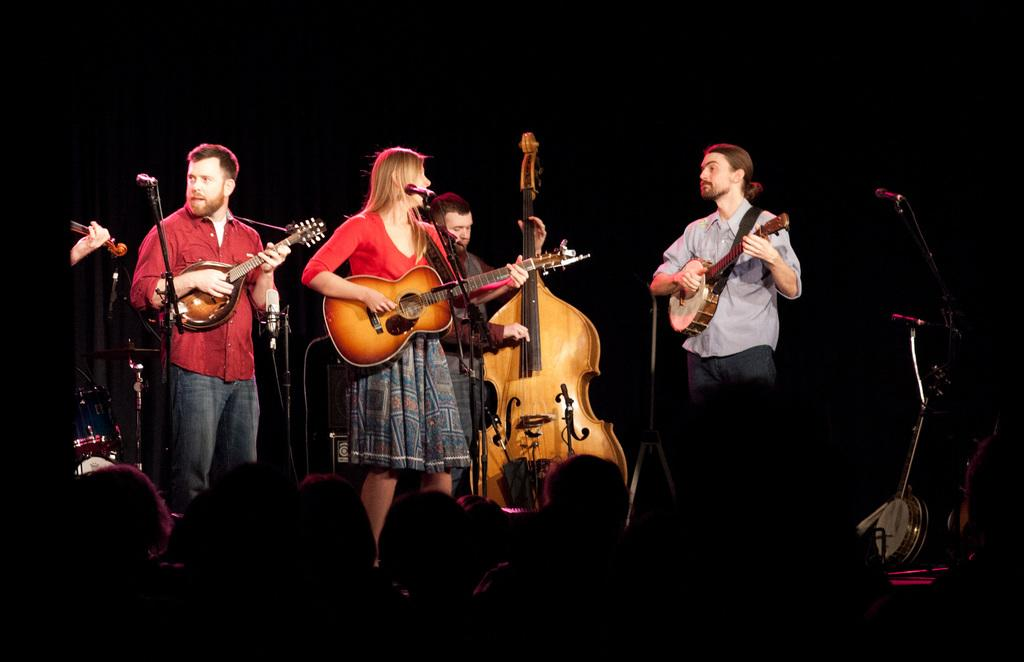How many people are on the dais in the image? There are four men on a dais in the image. What is one of the men doing on the dais? One of the men is playing a guitar. Are there any other musicians on the stage? Yes, there is a man playing a violin on the stage. Reasoning: Let' Let's think step by step in order to produce the conversation. We start by identifying the main subject of the image, which is the four men on the dais. Then, we describe the actions of one of the men, who is playing a guitar. Finally, we acknowledge the presence of another musician on the stage, who is playing a violin. Each question is designed to elicit a specific detail about the image that is known from the provided facts. Absurd Question/Answer: What time is displayed on the hourglass in the image? There is no hourglass present in the image. What type of container is holding the music notes in the image? There is no container holding music notes in the image. 